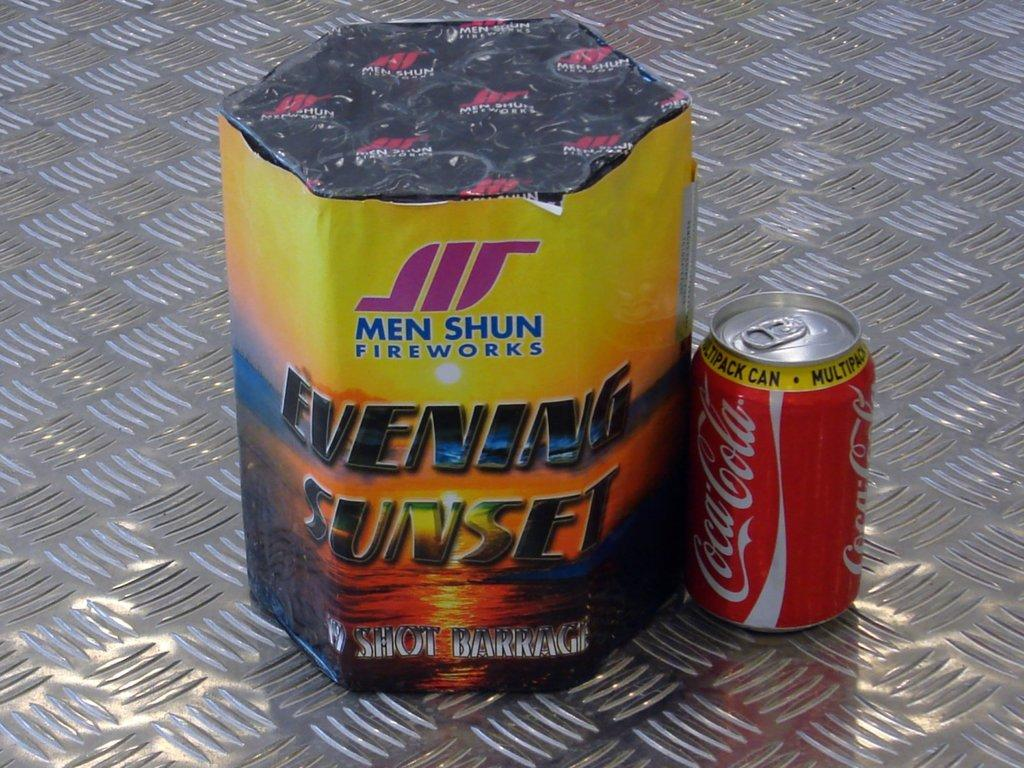<image>
Summarize the visual content of the image. A package of Men Shun fireworks sits next to a Coca-Cola can. 